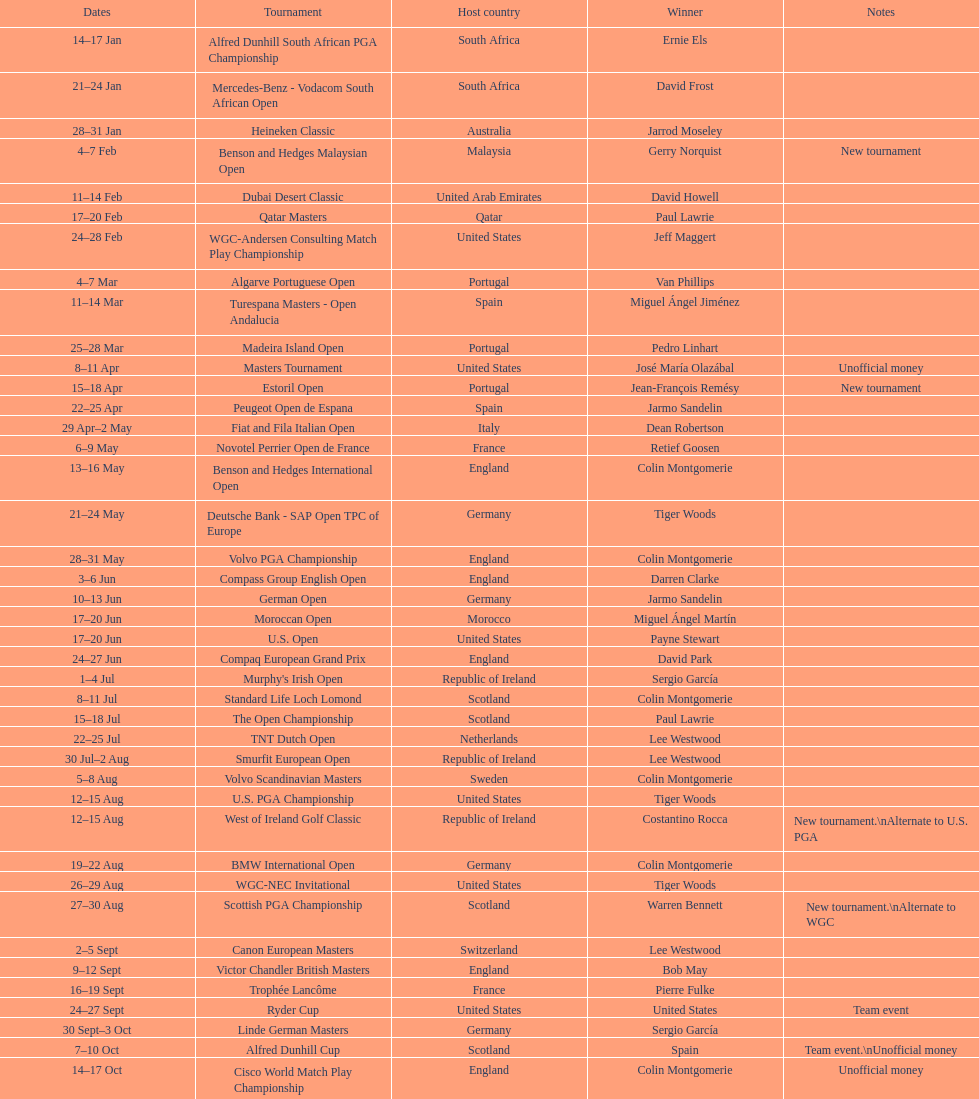How many competitions started before august 15th? 31. 